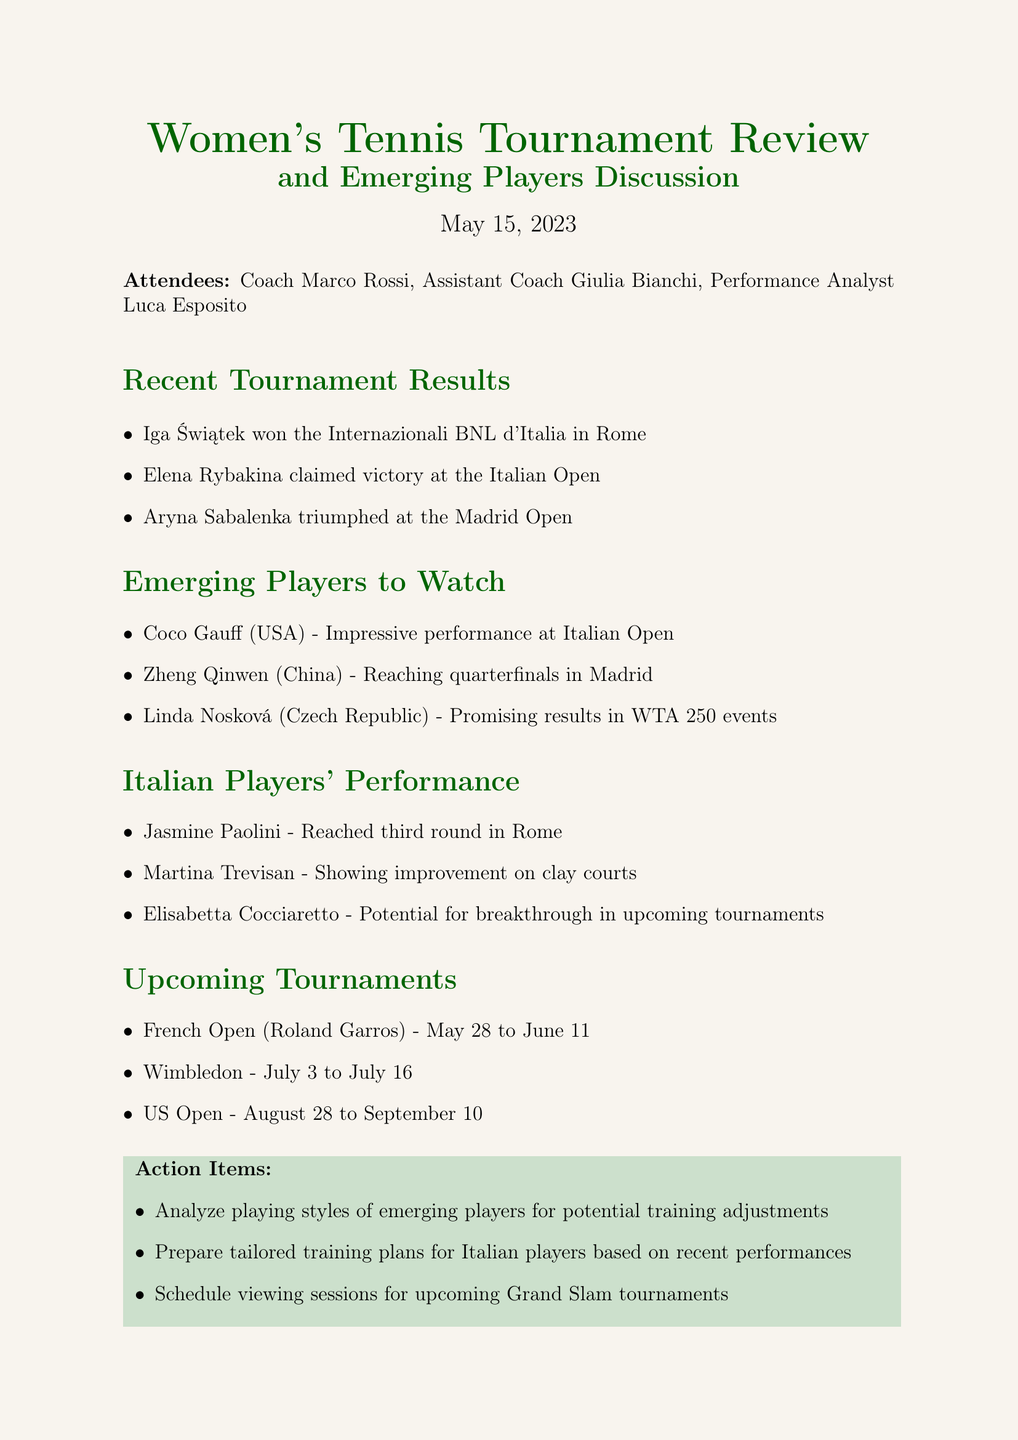What tournament did Iga Świątek win? The document states that Iga Świątek won the Internazionali BNL d'Italia in Rome.
Answer: Internazionali BNL d'Italia Who reached the quarterfinals in Madrid? The document mentions Zheng Qinwen from China reached the quarterfinals in Madrid.
Answer: Zheng Qinwen How many Italian players’ performances were discussed? The document lists three Italian players: Jasmine Paolini, Martina Trevisan, and Elisabetta Cocciaretto.
Answer: Three What is the date range for the French Open? The document specifies that the French Open is scheduled from May 28 to June 11.
Answer: May 28 to June 11 What action item involves training plans? One of the action items is to prepare tailored training plans for Italian players based on recent performances.
Answer: Prepare tailored training plans Which player had an impressive performance at the Italian Open? The document states that Coco Gauff had an impressive performance at the Italian Open.
Answer: Coco Gauff What type of document is this? This document is meeting minutes focused on reviewing women's tennis tournament results and discussing players.
Answer: Meeting minutes Who are the attendees? The document lists Coach Marco Rossi, Assistant Coach Giulia Bianchi, and Performance Analyst Luca Esposito as attendees.
Answer: Coach Marco Rossi, Assistant Coach Giulia Bianchi, Performance Analyst Luca Esposito 